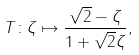<formula> <loc_0><loc_0><loc_500><loc_500>T \colon \zeta \mapsto \frac { \sqrt { 2 } - \zeta } { 1 + \sqrt { 2 } \zeta } ,</formula> 